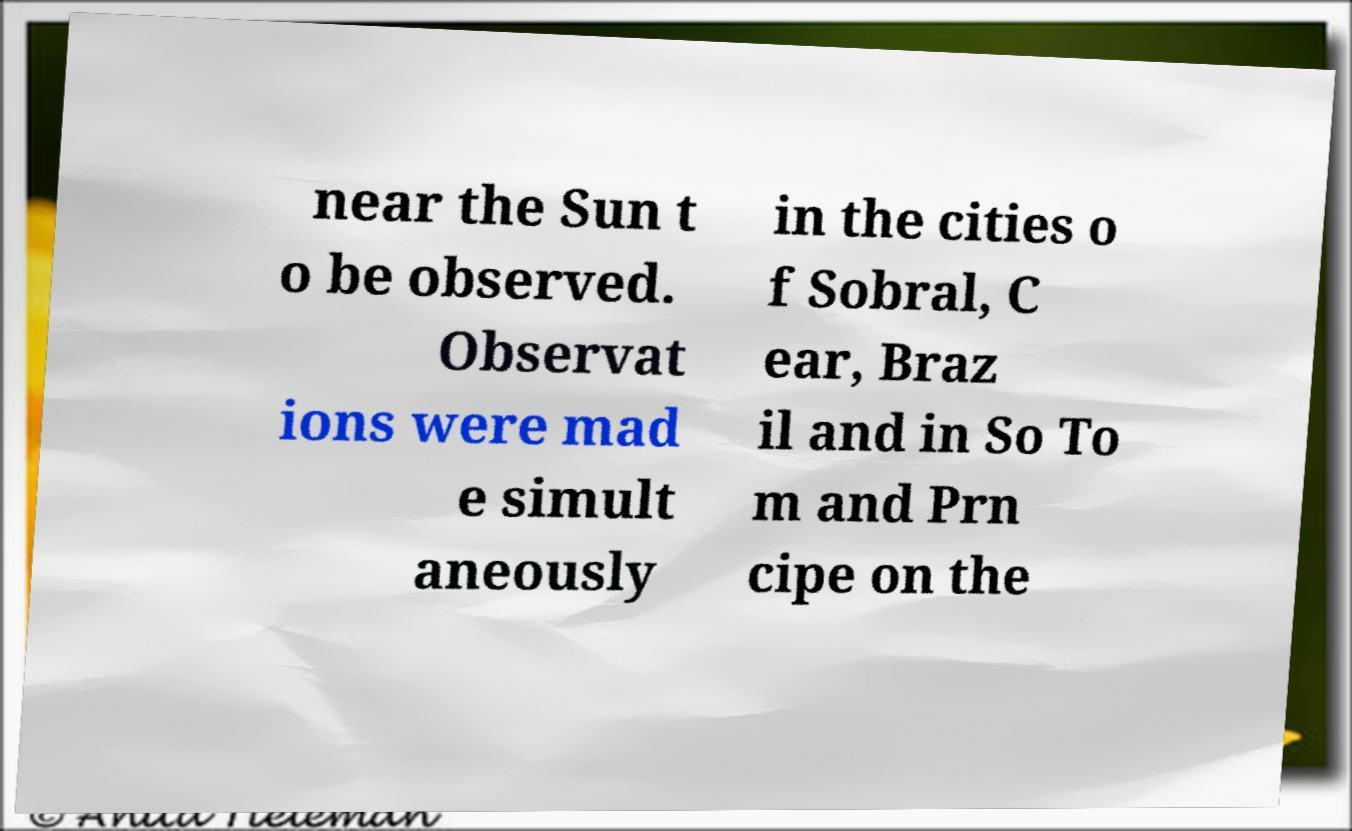Please read and relay the text visible in this image. What does it say? near the Sun t o be observed. Observat ions were mad e simult aneously in the cities o f Sobral, C ear, Braz il and in So To m and Prn cipe on the 